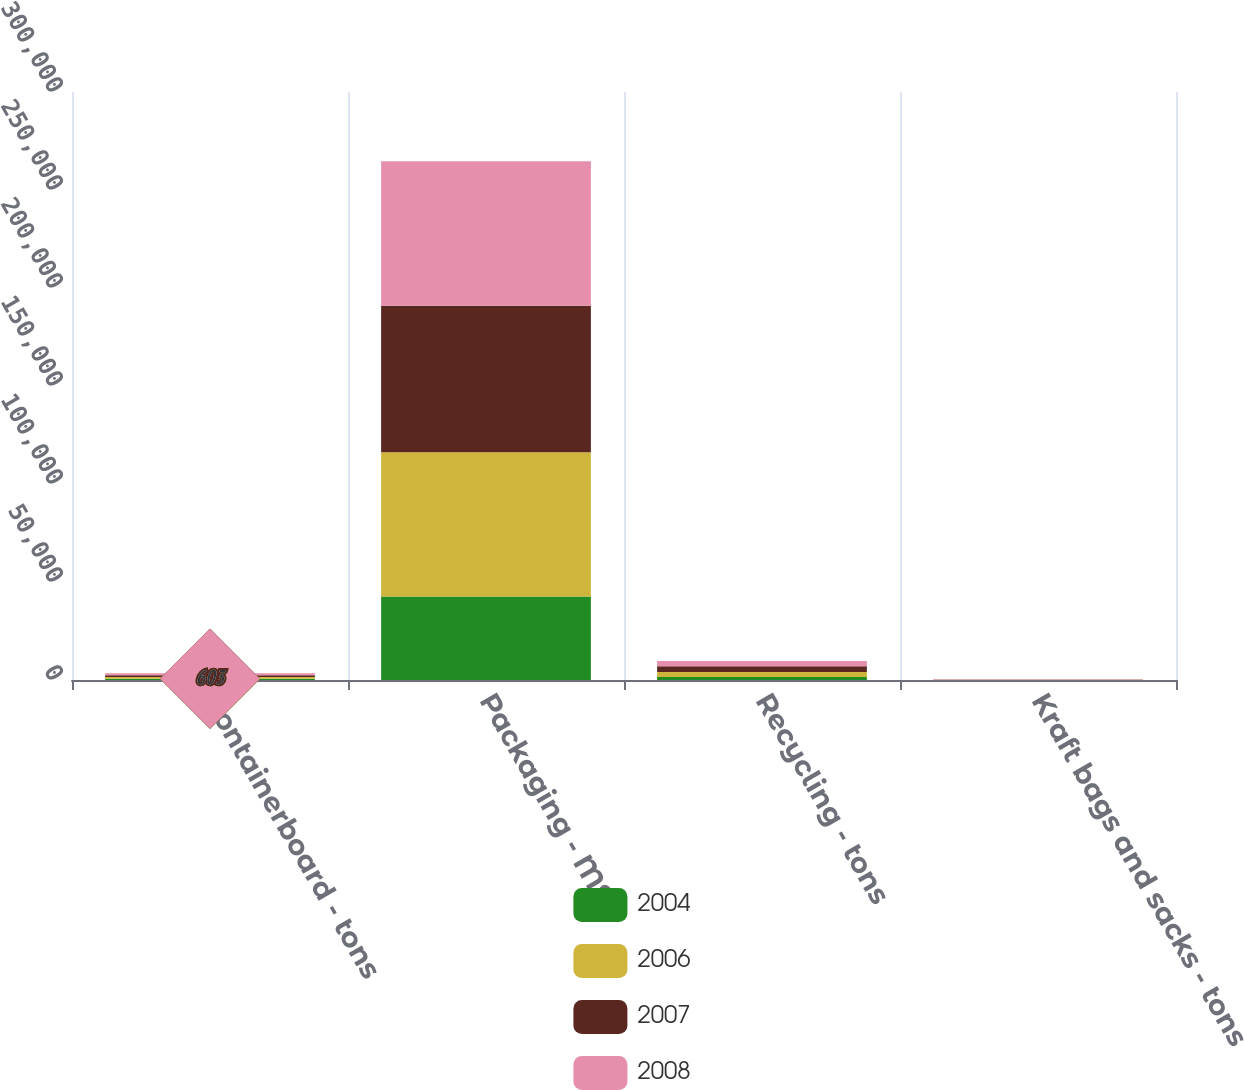Convert chart to OTSL. <chart><loc_0><loc_0><loc_500><loc_500><stacked_bar_chart><ecel><fcel>Containerboard - tons<fcel>Packaging - MSF<fcel>Recycling - tons<fcel>Kraft bags and sacks - tons<nl><fcel>2004<fcel>603<fcel>42566<fcel>1556<fcel>56<nl><fcel>2006<fcel>957<fcel>73572<fcel>2580<fcel>99<nl><fcel>2007<fcel>856<fcel>74867<fcel>2875<fcel>89<nl><fcel>2008<fcel>1046<fcel>73631<fcel>2728<fcel>89<nl></chart> 